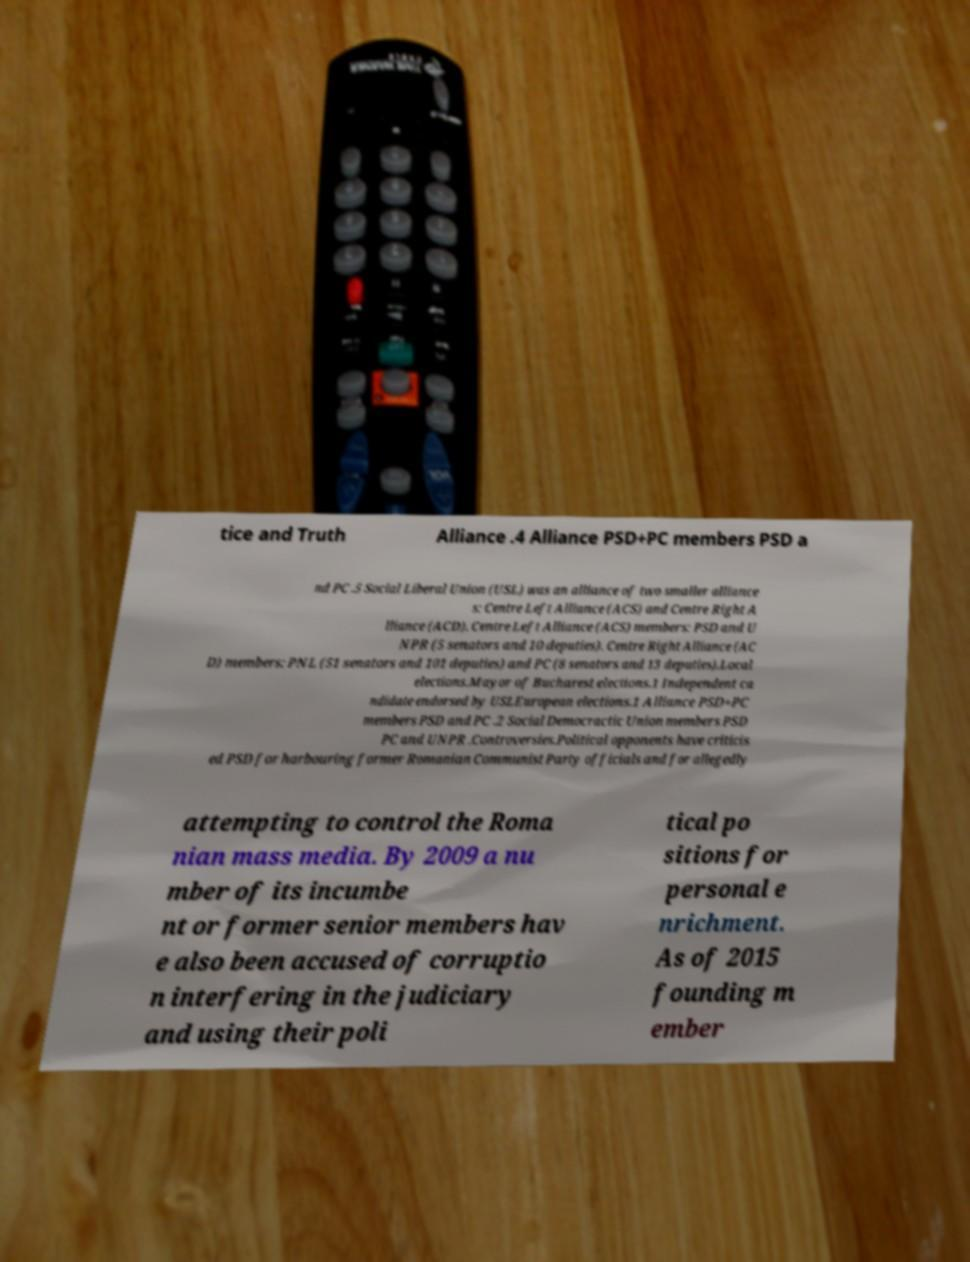What messages or text are displayed in this image? I need them in a readable, typed format. tice and Truth Alliance .4 Alliance PSD+PC members PSD a nd PC .5 Social Liberal Union (USL) was an alliance of two smaller alliance s: Centre Left Alliance (ACS) and Centre Right A lliance (ACD). Centre Left Alliance (ACS) members: PSD and U NPR (5 senators and 10 deputies). Centre Right Alliance (AC D) members: PNL (51 senators and 101 deputies) and PC (8 senators and 13 deputies).Local elections.Mayor of Bucharest elections.1 Independent ca ndidate endorsed by USLEuropean elections.1 Alliance PSD+PC members PSD and PC .2 Social Democractic Union members PSD PC and UNPR .Controversies.Political opponents have criticis ed PSD for harbouring former Romanian Communist Party officials and for allegedly attempting to control the Roma nian mass media. By 2009 a nu mber of its incumbe nt or former senior members hav e also been accused of corruptio n interfering in the judiciary and using their poli tical po sitions for personal e nrichment. As of 2015 founding m ember 